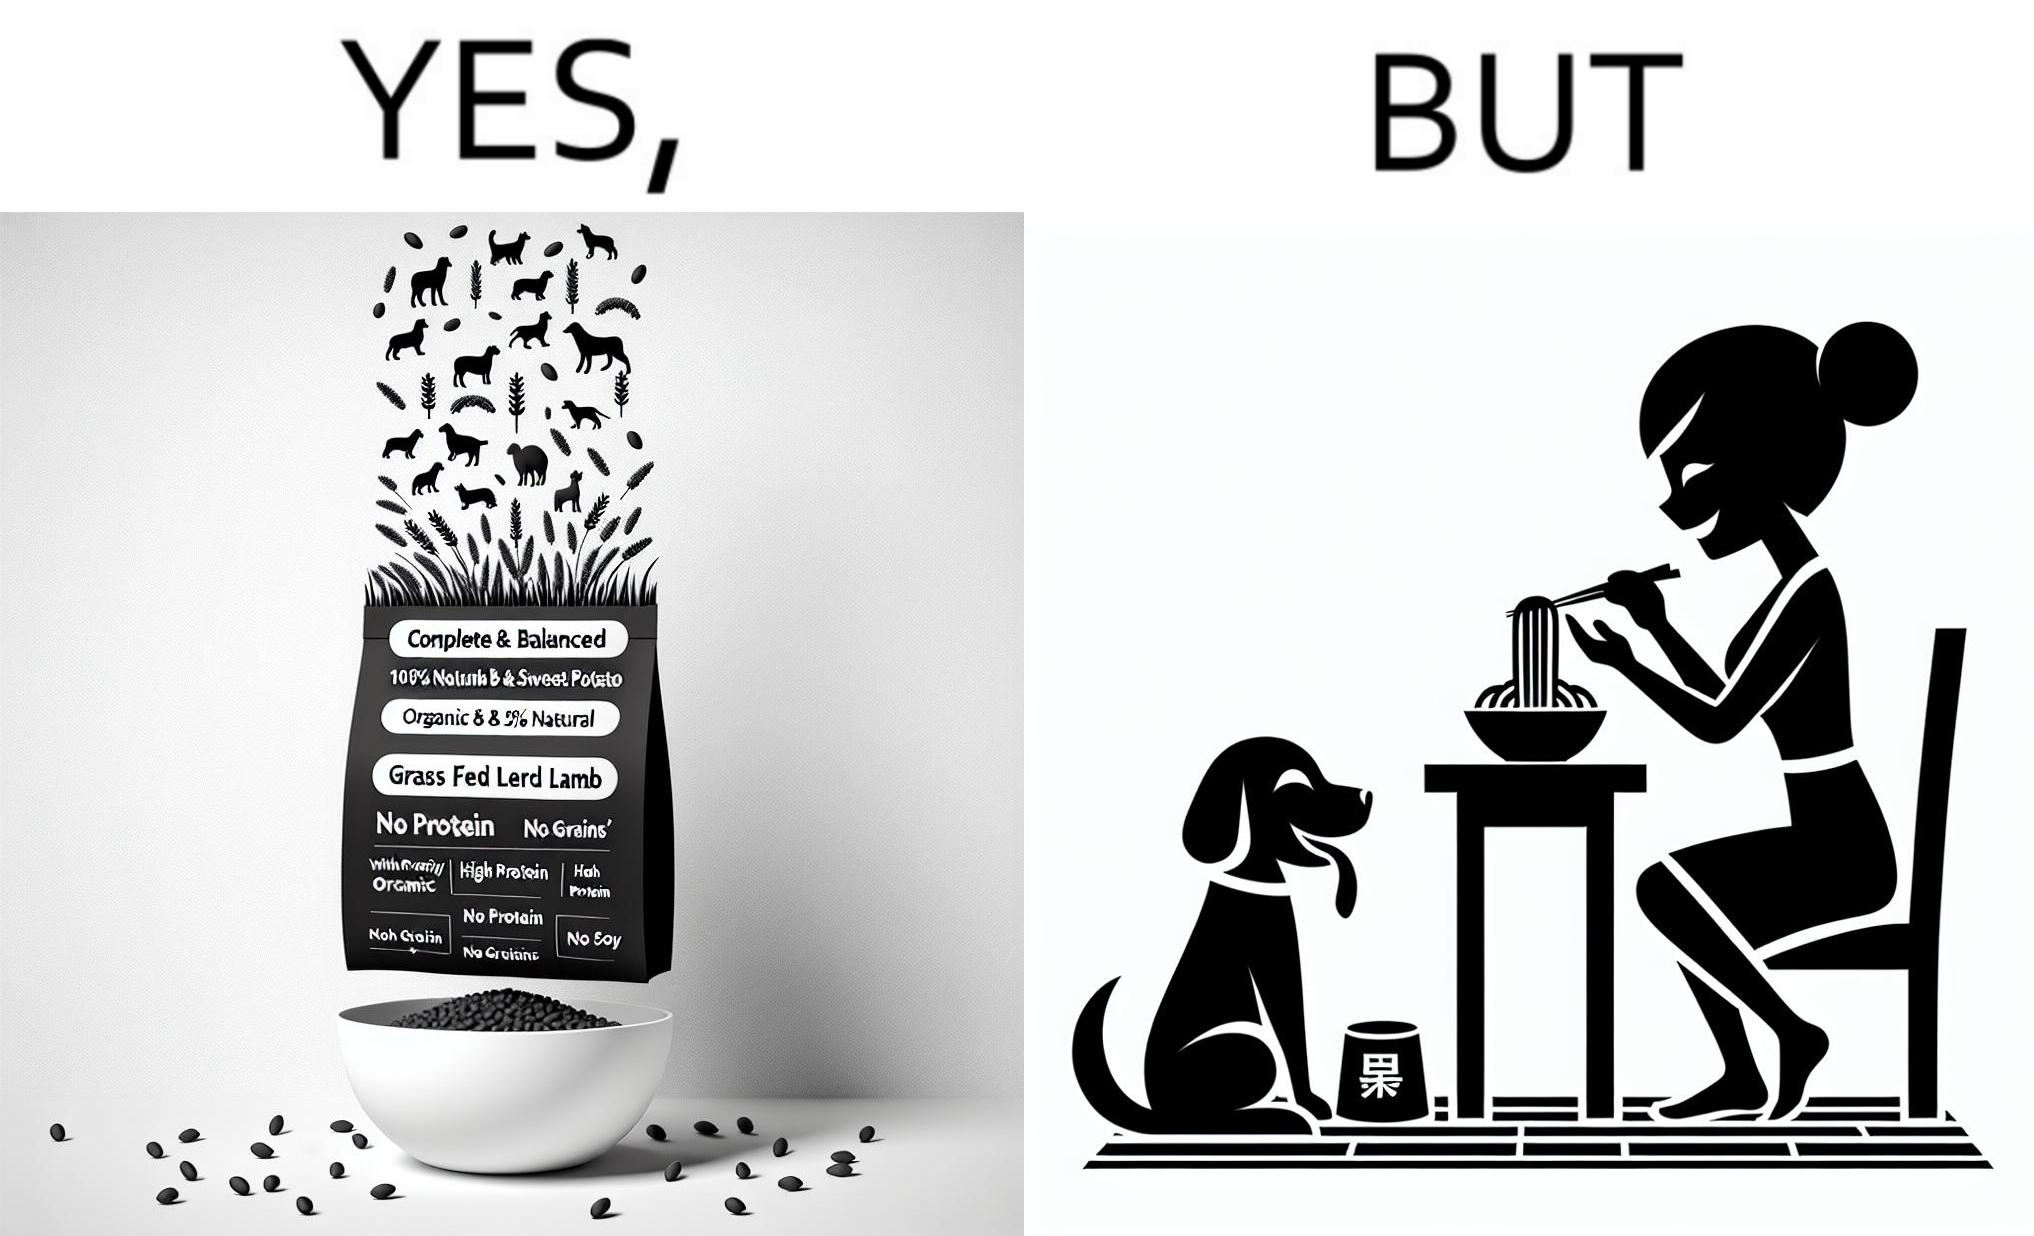Describe the content of this image. The image is funny because while the food for the dog that the woman pours is well balanced, the food that she herself is eating is bad for her health. 